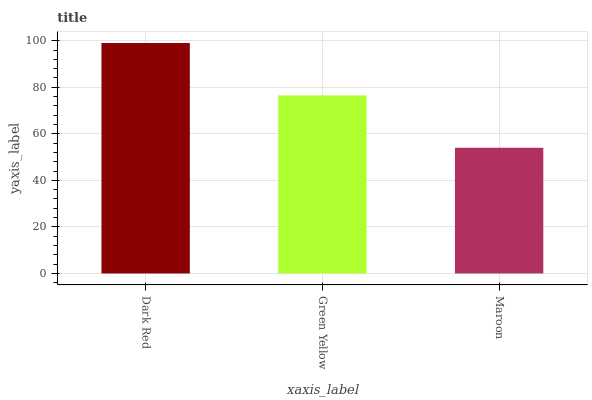Is Green Yellow the minimum?
Answer yes or no. No. Is Green Yellow the maximum?
Answer yes or no. No. Is Dark Red greater than Green Yellow?
Answer yes or no. Yes. Is Green Yellow less than Dark Red?
Answer yes or no. Yes. Is Green Yellow greater than Dark Red?
Answer yes or no. No. Is Dark Red less than Green Yellow?
Answer yes or no. No. Is Green Yellow the high median?
Answer yes or no. Yes. Is Green Yellow the low median?
Answer yes or no. Yes. Is Dark Red the high median?
Answer yes or no. No. Is Maroon the low median?
Answer yes or no. No. 